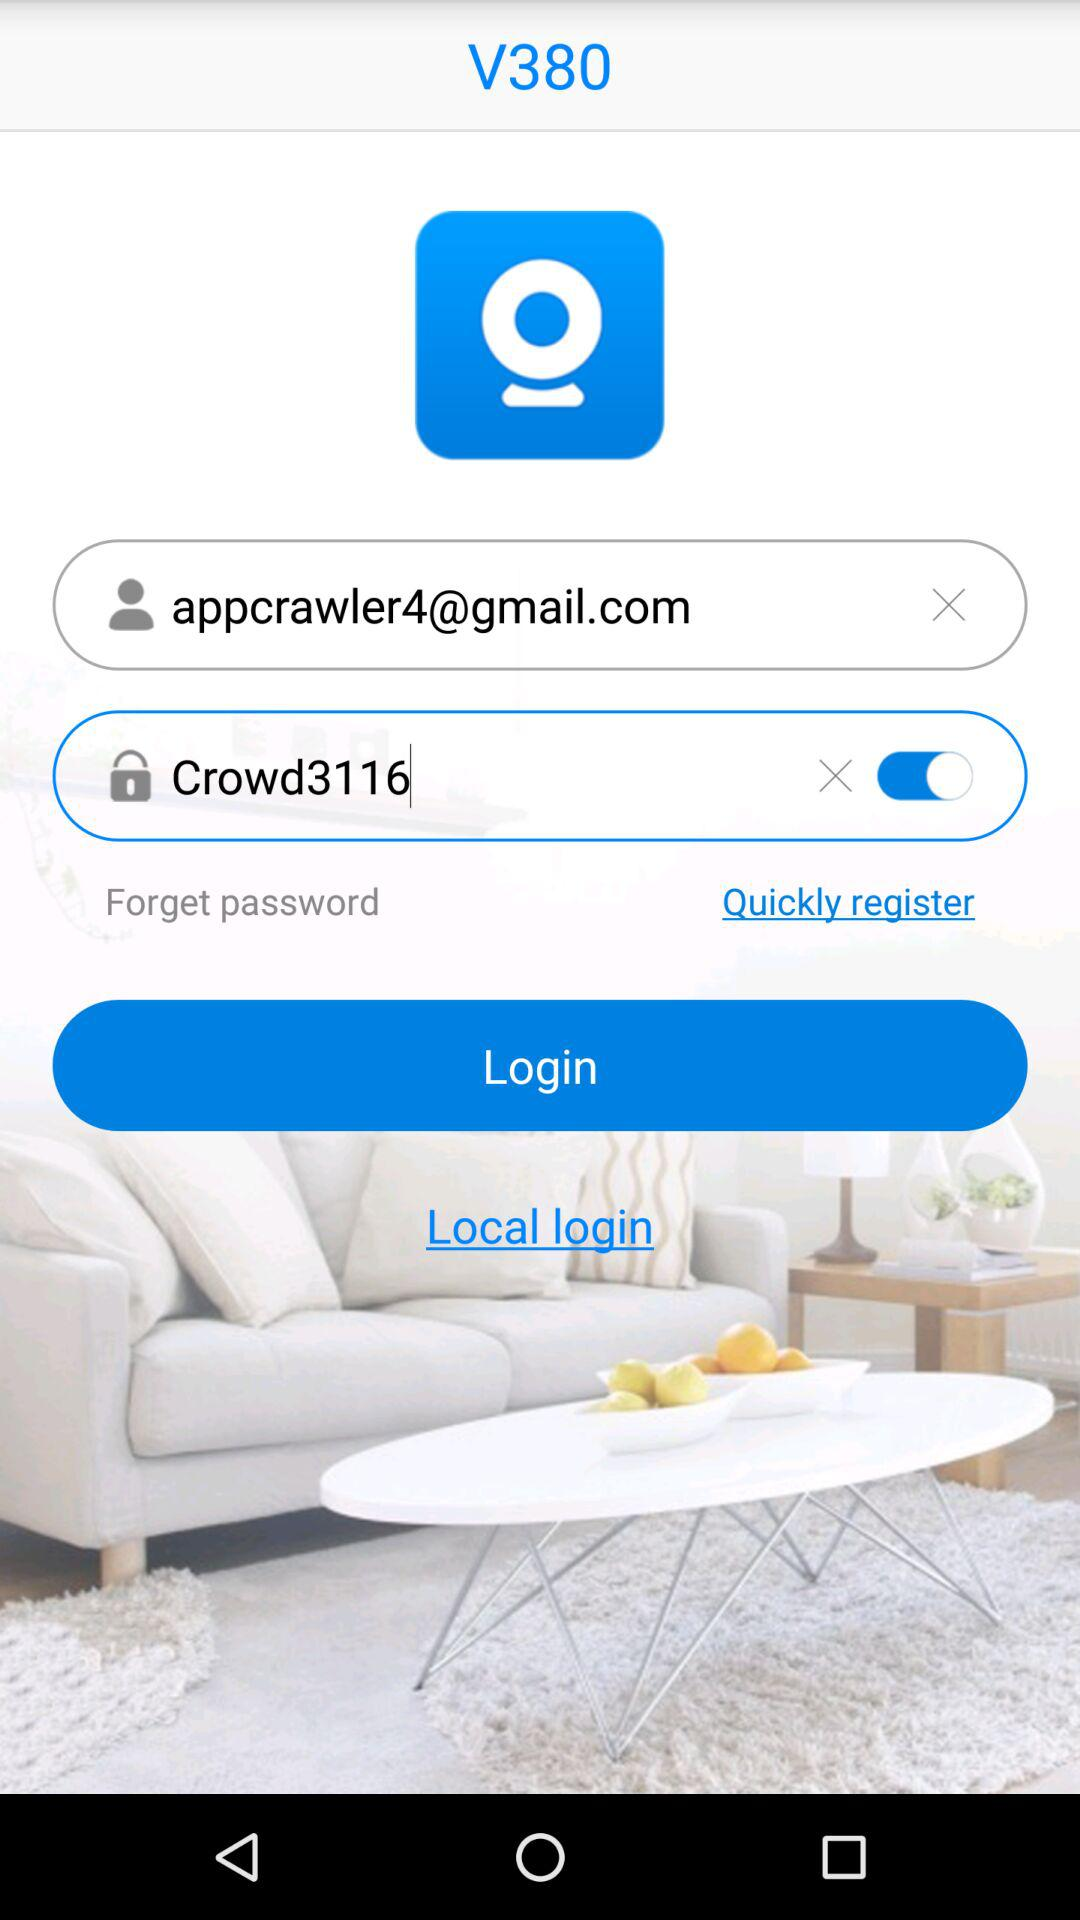What is the email address? The email address is appcrawler4@gmail.com. 